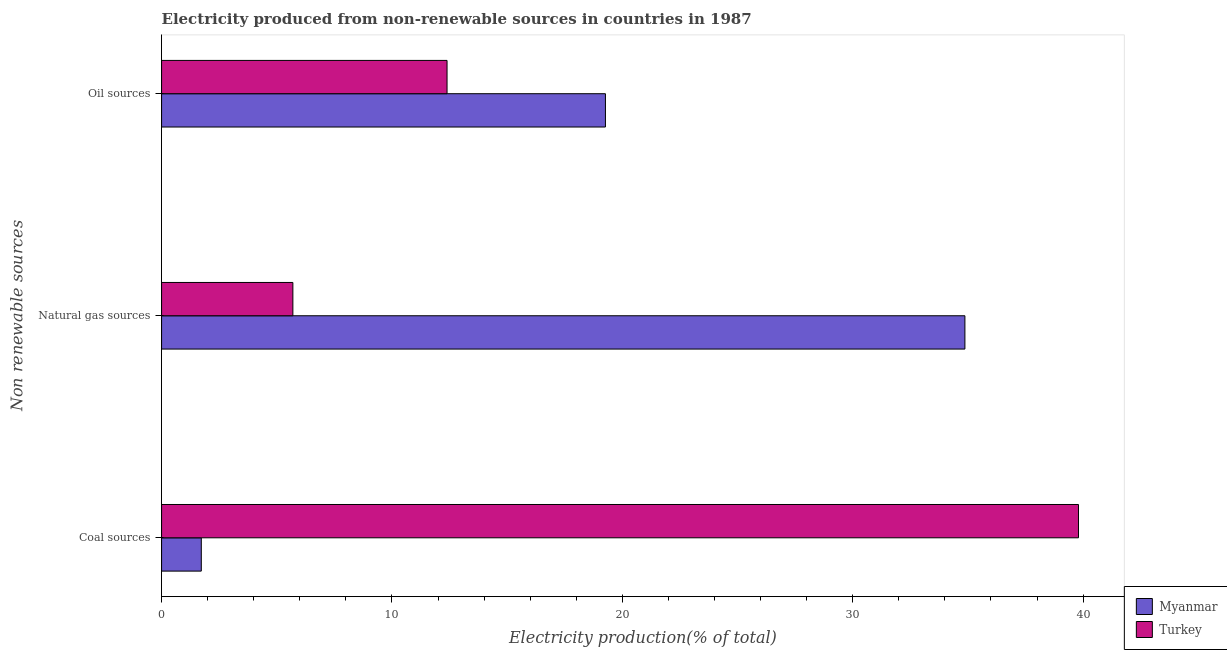How many different coloured bars are there?
Offer a very short reply. 2. Are the number of bars per tick equal to the number of legend labels?
Your answer should be compact. Yes. Are the number of bars on each tick of the Y-axis equal?
Make the answer very short. Yes. How many bars are there on the 3rd tick from the bottom?
Give a very brief answer. 2. What is the label of the 2nd group of bars from the top?
Keep it short and to the point. Natural gas sources. What is the percentage of electricity produced by coal in Myanmar?
Provide a short and direct response. 1.72. Across all countries, what is the maximum percentage of electricity produced by oil sources?
Ensure brevity in your answer.  19.27. Across all countries, what is the minimum percentage of electricity produced by oil sources?
Your response must be concise. 12.39. In which country was the percentage of electricity produced by oil sources maximum?
Your answer should be very brief. Myanmar. What is the total percentage of electricity produced by oil sources in the graph?
Ensure brevity in your answer.  31.66. What is the difference between the percentage of electricity produced by oil sources in Turkey and that in Myanmar?
Give a very brief answer. -6.88. What is the difference between the percentage of electricity produced by coal in Myanmar and the percentage of electricity produced by natural gas in Turkey?
Provide a short and direct response. -3.98. What is the average percentage of electricity produced by oil sources per country?
Ensure brevity in your answer.  15.83. What is the difference between the percentage of electricity produced by oil sources and percentage of electricity produced by coal in Turkey?
Keep it short and to the point. -27.41. What is the ratio of the percentage of electricity produced by natural gas in Turkey to that in Myanmar?
Keep it short and to the point. 0.16. Is the percentage of electricity produced by natural gas in Turkey less than that in Myanmar?
Make the answer very short. Yes. Is the difference between the percentage of electricity produced by natural gas in Myanmar and Turkey greater than the difference between the percentage of electricity produced by coal in Myanmar and Turkey?
Provide a succinct answer. Yes. What is the difference between the highest and the second highest percentage of electricity produced by natural gas?
Offer a terse response. 29.17. What is the difference between the highest and the lowest percentage of electricity produced by coal?
Keep it short and to the point. 38.08. Is the sum of the percentage of electricity produced by coal in Turkey and Myanmar greater than the maximum percentage of electricity produced by natural gas across all countries?
Keep it short and to the point. Yes. What does the 1st bar from the top in Coal sources represents?
Keep it short and to the point. Turkey. What does the 2nd bar from the bottom in Coal sources represents?
Your response must be concise. Turkey. Is it the case that in every country, the sum of the percentage of electricity produced by coal and percentage of electricity produced by natural gas is greater than the percentage of electricity produced by oil sources?
Provide a short and direct response. Yes. How many bars are there?
Make the answer very short. 6. Are all the bars in the graph horizontal?
Keep it short and to the point. Yes. How many countries are there in the graph?
Offer a terse response. 2. What is the difference between two consecutive major ticks on the X-axis?
Give a very brief answer. 10. Are the values on the major ticks of X-axis written in scientific E-notation?
Provide a succinct answer. No. Does the graph contain any zero values?
Provide a short and direct response. No. Does the graph contain grids?
Keep it short and to the point. No. Where does the legend appear in the graph?
Make the answer very short. Bottom right. How many legend labels are there?
Give a very brief answer. 2. What is the title of the graph?
Your response must be concise. Electricity produced from non-renewable sources in countries in 1987. What is the label or title of the Y-axis?
Provide a short and direct response. Non renewable sources. What is the Electricity production(% of total) in Myanmar in Coal sources?
Your answer should be compact. 1.72. What is the Electricity production(% of total) in Turkey in Coal sources?
Offer a terse response. 39.8. What is the Electricity production(% of total) of Myanmar in Natural gas sources?
Keep it short and to the point. 34.87. What is the Electricity production(% of total) in Turkey in Natural gas sources?
Ensure brevity in your answer.  5.7. What is the Electricity production(% of total) in Myanmar in Oil sources?
Provide a succinct answer. 19.27. What is the Electricity production(% of total) of Turkey in Oil sources?
Provide a short and direct response. 12.39. Across all Non renewable sources, what is the maximum Electricity production(% of total) in Myanmar?
Keep it short and to the point. 34.87. Across all Non renewable sources, what is the maximum Electricity production(% of total) in Turkey?
Offer a terse response. 39.8. Across all Non renewable sources, what is the minimum Electricity production(% of total) in Myanmar?
Your answer should be very brief. 1.72. Across all Non renewable sources, what is the minimum Electricity production(% of total) of Turkey?
Your response must be concise. 5.7. What is the total Electricity production(% of total) of Myanmar in the graph?
Keep it short and to the point. 55.86. What is the total Electricity production(% of total) in Turkey in the graph?
Ensure brevity in your answer.  57.89. What is the difference between the Electricity production(% of total) in Myanmar in Coal sources and that in Natural gas sources?
Your answer should be compact. -33.15. What is the difference between the Electricity production(% of total) of Turkey in Coal sources and that in Natural gas sources?
Offer a very short reply. 34.1. What is the difference between the Electricity production(% of total) in Myanmar in Coal sources and that in Oil sources?
Make the answer very short. -17.54. What is the difference between the Electricity production(% of total) of Turkey in Coal sources and that in Oil sources?
Give a very brief answer. 27.41. What is the difference between the Electricity production(% of total) in Myanmar in Natural gas sources and that in Oil sources?
Keep it short and to the point. 15.6. What is the difference between the Electricity production(% of total) of Turkey in Natural gas sources and that in Oil sources?
Make the answer very short. -6.69. What is the difference between the Electricity production(% of total) in Myanmar in Coal sources and the Electricity production(% of total) in Turkey in Natural gas sources?
Give a very brief answer. -3.98. What is the difference between the Electricity production(% of total) of Myanmar in Coal sources and the Electricity production(% of total) of Turkey in Oil sources?
Keep it short and to the point. -10.67. What is the difference between the Electricity production(% of total) in Myanmar in Natural gas sources and the Electricity production(% of total) in Turkey in Oil sources?
Your answer should be compact. 22.48. What is the average Electricity production(% of total) in Myanmar per Non renewable sources?
Keep it short and to the point. 18.62. What is the average Electricity production(% of total) of Turkey per Non renewable sources?
Your response must be concise. 19.3. What is the difference between the Electricity production(% of total) in Myanmar and Electricity production(% of total) in Turkey in Coal sources?
Ensure brevity in your answer.  -38.08. What is the difference between the Electricity production(% of total) of Myanmar and Electricity production(% of total) of Turkey in Natural gas sources?
Provide a short and direct response. 29.17. What is the difference between the Electricity production(% of total) in Myanmar and Electricity production(% of total) in Turkey in Oil sources?
Offer a very short reply. 6.88. What is the ratio of the Electricity production(% of total) of Myanmar in Coal sources to that in Natural gas sources?
Provide a succinct answer. 0.05. What is the ratio of the Electricity production(% of total) of Turkey in Coal sources to that in Natural gas sources?
Offer a terse response. 6.98. What is the ratio of the Electricity production(% of total) in Myanmar in Coal sources to that in Oil sources?
Offer a very short reply. 0.09. What is the ratio of the Electricity production(% of total) in Turkey in Coal sources to that in Oil sources?
Provide a succinct answer. 3.21. What is the ratio of the Electricity production(% of total) of Myanmar in Natural gas sources to that in Oil sources?
Offer a very short reply. 1.81. What is the ratio of the Electricity production(% of total) of Turkey in Natural gas sources to that in Oil sources?
Give a very brief answer. 0.46. What is the difference between the highest and the second highest Electricity production(% of total) of Myanmar?
Keep it short and to the point. 15.6. What is the difference between the highest and the second highest Electricity production(% of total) of Turkey?
Provide a short and direct response. 27.41. What is the difference between the highest and the lowest Electricity production(% of total) in Myanmar?
Offer a very short reply. 33.15. What is the difference between the highest and the lowest Electricity production(% of total) in Turkey?
Your answer should be very brief. 34.1. 